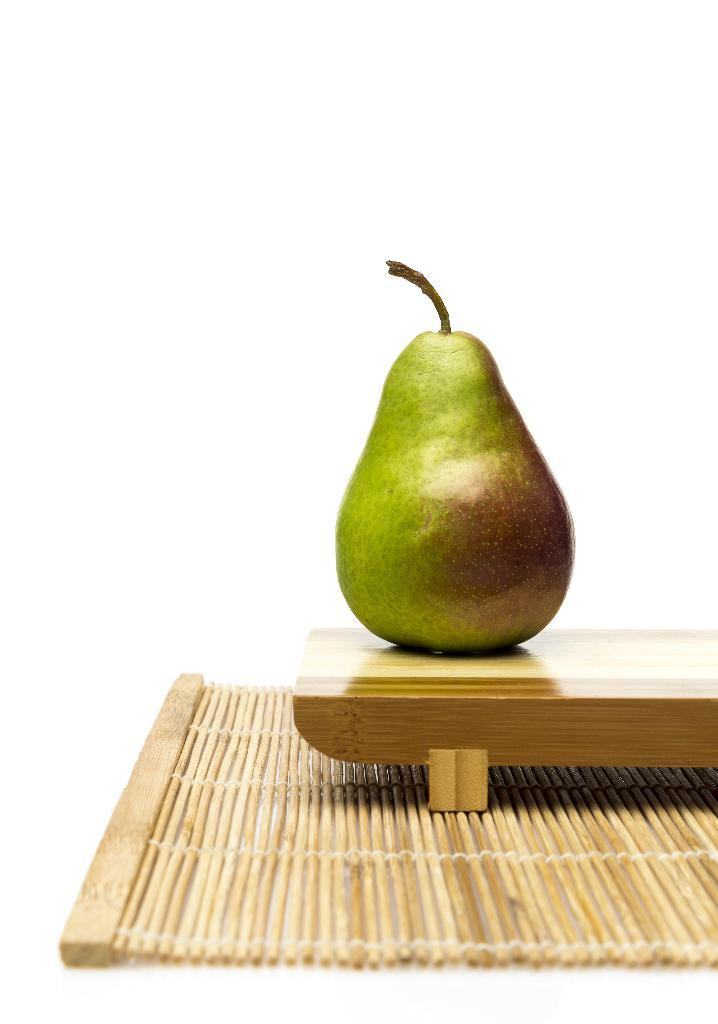What type of fruit is in the image? There is a pear fruit in the image. Where is the pear fruit located? The pear fruit is on a wooden table. What other wooden object is present in the image? There is a wooden mat in the image. What color is the background of the image? The background of the image is white in color. What type of lead can be seen in the image? There is no lead present in the image. Is it raining in the image? The image does not show any indication of rain. 